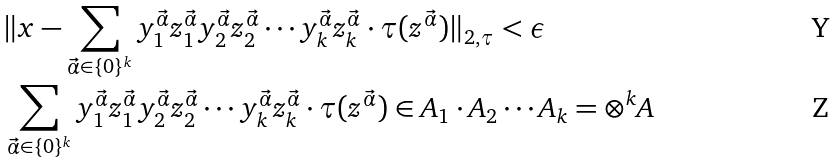Convert formula to latex. <formula><loc_0><loc_0><loc_500><loc_500>& \| x - \sum _ { \vec { \alpha } \in \{ 0 \} ^ { k } } y _ { 1 } ^ { \vec { \alpha } } z _ { 1 } ^ { \vec { \alpha } } y _ { 2 } ^ { \vec { \alpha } } z _ { 2 } ^ { \vec { \alpha } } \cdots y _ { k } ^ { \vec { \alpha } } z _ { k } ^ { \vec { \alpha } } \cdot \tau ( z ^ { \vec { \alpha } } ) \| _ { 2 , \tau } < \epsilon \\ & \sum _ { \vec { \alpha } \in \{ 0 \} ^ { k } } y _ { 1 } ^ { \vec { \alpha } } z _ { 1 } ^ { \vec { \alpha } } y _ { 2 } ^ { \vec { \alpha } } z _ { 2 } ^ { \vec { \alpha } } \cdots y _ { k } ^ { \vec { \alpha } } z _ { k } ^ { \vec { \alpha } } \cdot \tau ( z ^ { \vec { \alpha } } ) \in A _ { 1 } \cdot A _ { 2 } \cdots A _ { k } = \otimes ^ { k } A</formula> 